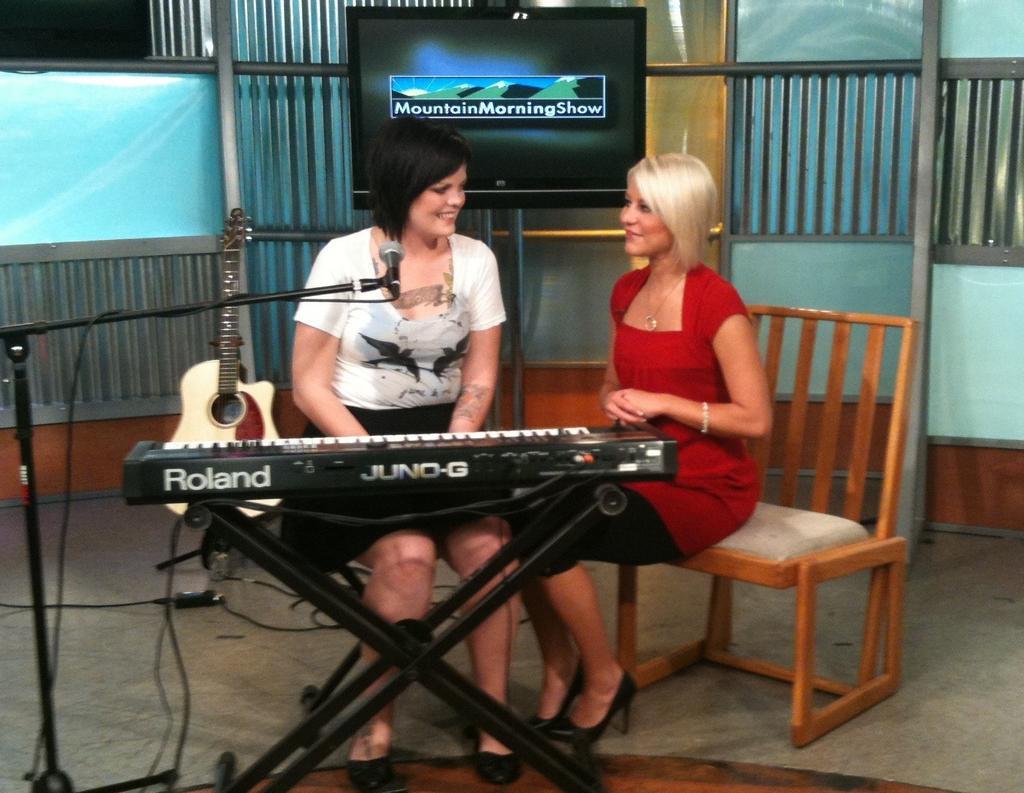Could you give a brief overview of what you see in this image? In this image there are chairs, people, musical instruments in the foreground. There is a floor at the bottom. There is a wall with screen in the background. 